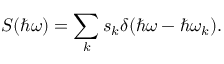Convert formula to latex. <formula><loc_0><loc_0><loc_500><loc_500>S ( \hbar { \omega } ) = \sum _ { k } s _ { k } \delta ( \hbar { \omega } - \hbar { \omega } _ { k } ) .</formula> 